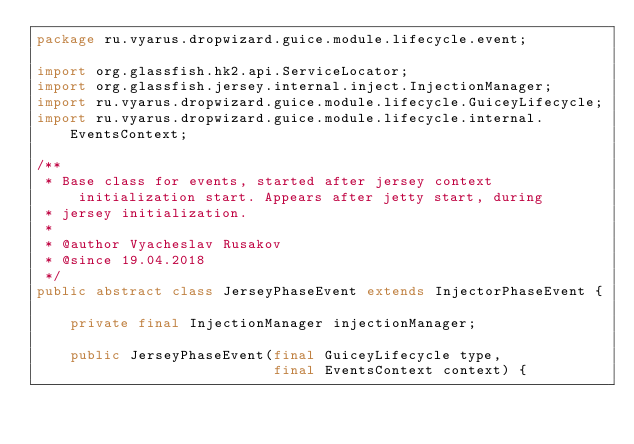Convert code to text. <code><loc_0><loc_0><loc_500><loc_500><_Java_>package ru.vyarus.dropwizard.guice.module.lifecycle.event;

import org.glassfish.hk2.api.ServiceLocator;
import org.glassfish.jersey.internal.inject.InjectionManager;
import ru.vyarus.dropwizard.guice.module.lifecycle.GuiceyLifecycle;
import ru.vyarus.dropwizard.guice.module.lifecycle.internal.EventsContext;

/**
 * Base class for events, started after jersey context initialization start. Appears after jetty start, during
 * jersey initialization.
 *
 * @author Vyacheslav Rusakov
 * @since 19.04.2018
 */
public abstract class JerseyPhaseEvent extends InjectorPhaseEvent {

    private final InjectionManager injectionManager;

    public JerseyPhaseEvent(final GuiceyLifecycle type,
                            final EventsContext context) {</code> 